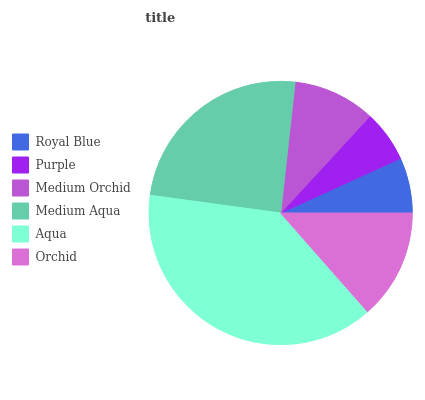Is Purple the minimum?
Answer yes or no. Yes. Is Aqua the maximum?
Answer yes or no. Yes. Is Medium Orchid the minimum?
Answer yes or no. No. Is Medium Orchid the maximum?
Answer yes or no. No. Is Medium Orchid greater than Purple?
Answer yes or no. Yes. Is Purple less than Medium Orchid?
Answer yes or no. Yes. Is Purple greater than Medium Orchid?
Answer yes or no. No. Is Medium Orchid less than Purple?
Answer yes or no. No. Is Orchid the high median?
Answer yes or no. Yes. Is Medium Orchid the low median?
Answer yes or no. Yes. Is Aqua the high median?
Answer yes or no. No. Is Purple the low median?
Answer yes or no. No. 